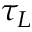Convert formula to latex. <formula><loc_0><loc_0><loc_500><loc_500>\tau _ { L }</formula> 